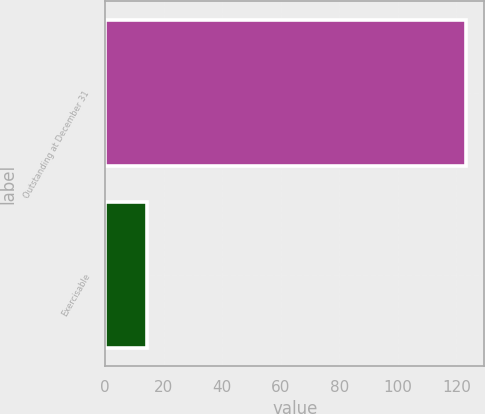Convert chart. <chart><loc_0><loc_0><loc_500><loc_500><bar_chart><fcel>Outstanding at December 31<fcel>Exercisable<nl><fcel>123.4<fcel>14.4<nl></chart> 